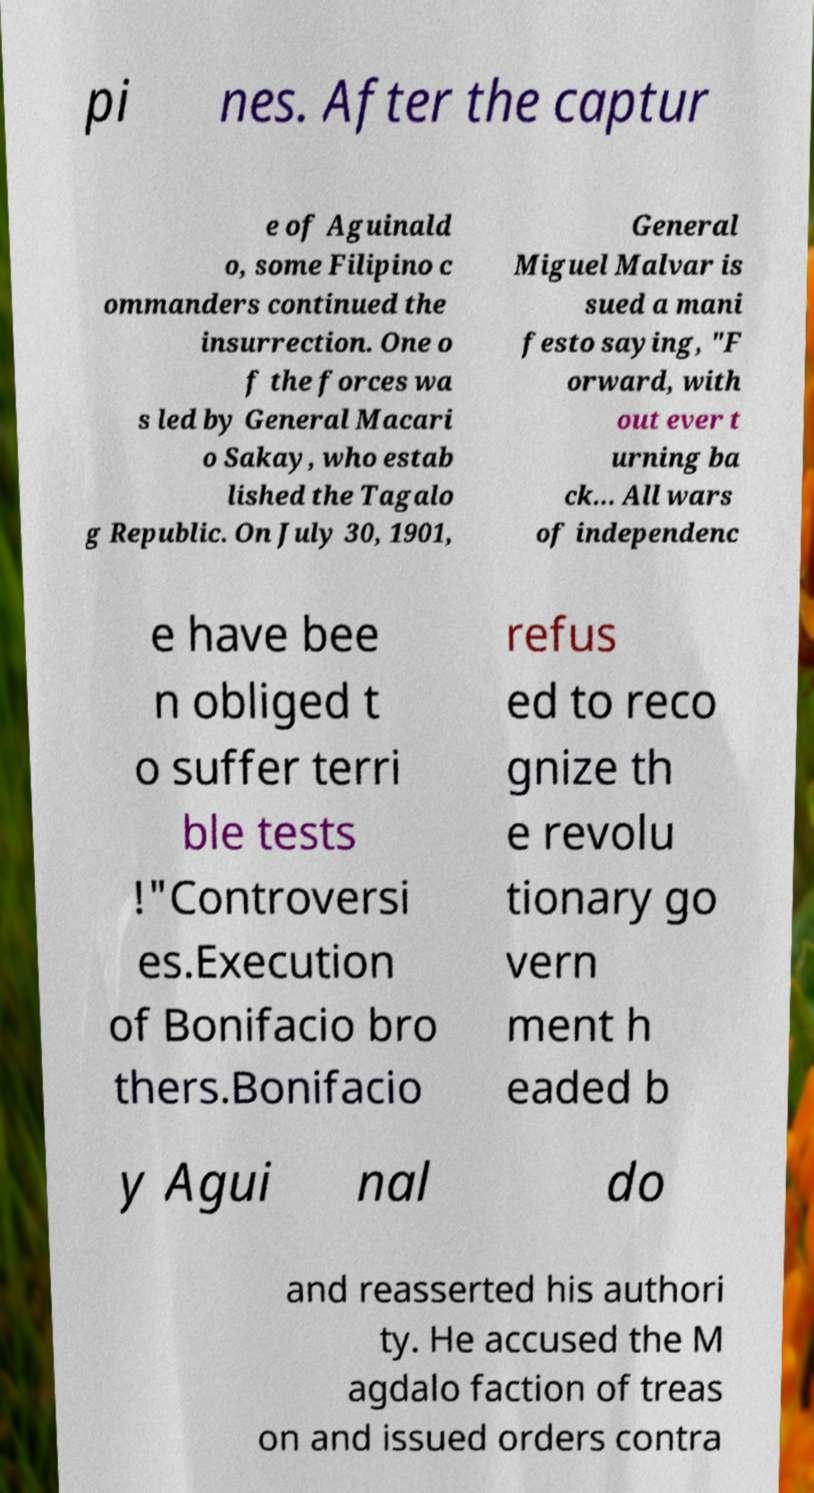Can you read and provide the text displayed in the image?This photo seems to have some interesting text. Can you extract and type it out for me? pi nes. After the captur e of Aguinald o, some Filipino c ommanders continued the insurrection. One o f the forces wa s led by General Macari o Sakay, who estab lished the Tagalo g Republic. On July 30, 1901, General Miguel Malvar is sued a mani festo saying, "F orward, with out ever t urning ba ck... All wars of independenc e have bee n obliged t o suffer terri ble tests !"Controversi es.Execution of Bonifacio bro thers.Bonifacio refus ed to reco gnize th e revolu tionary go vern ment h eaded b y Agui nal do and reasserted his authori ty. He accused the M agdalo faction of treas on and issued orders contra 